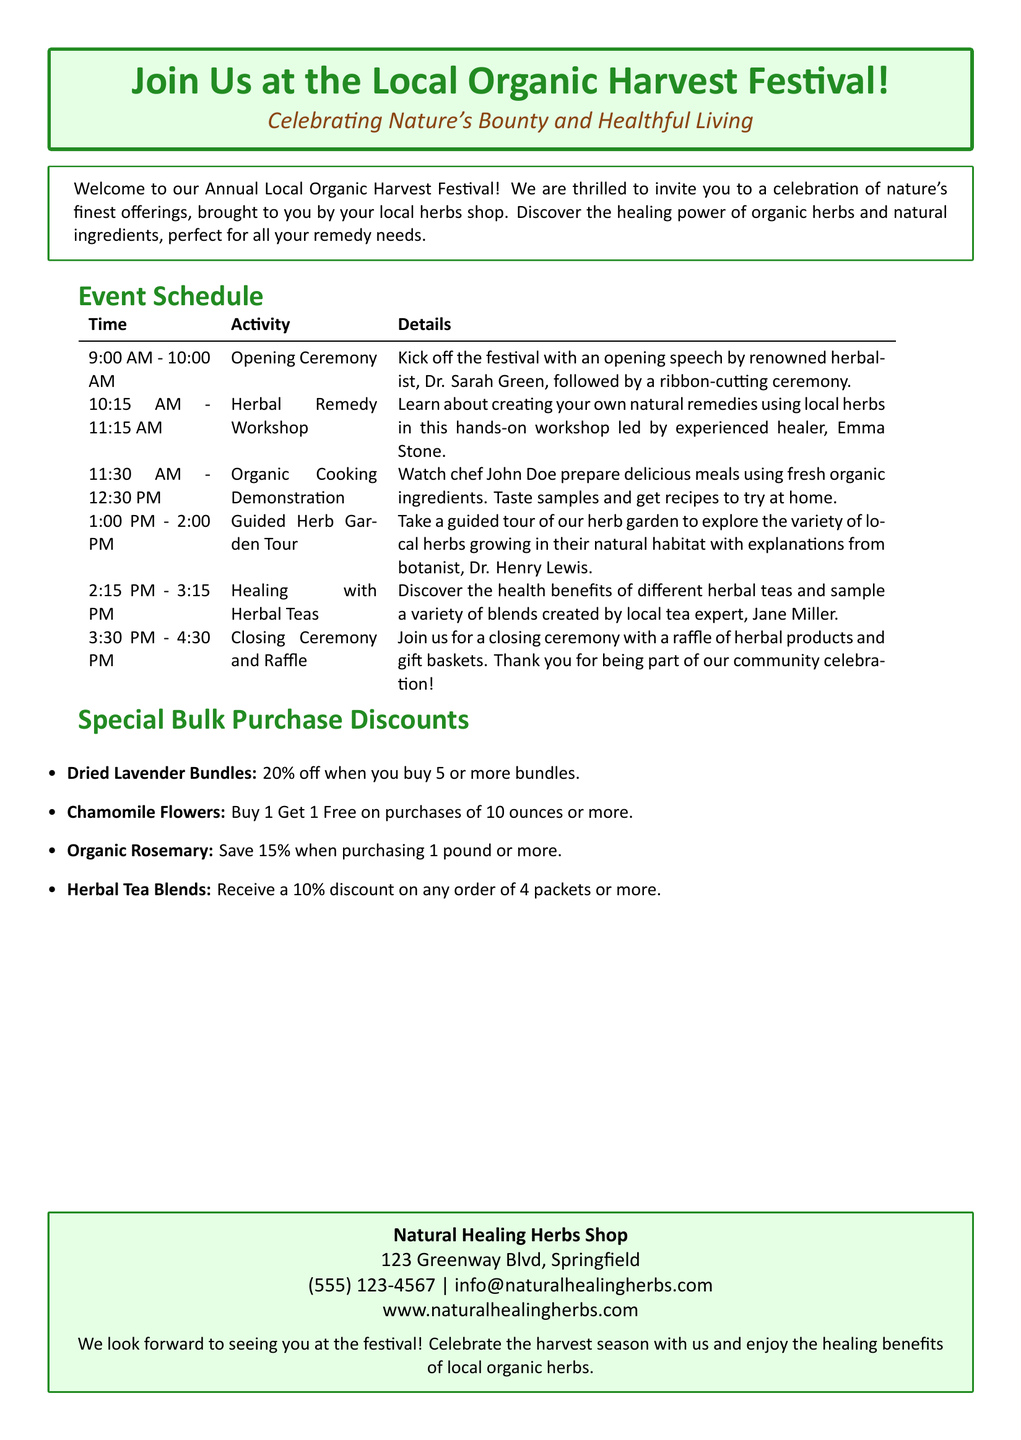What time does the festival begin? The opening ceremony kicks off the festival at 9:00 AM.
Answer: 9:00 AM Who is leading the Herbal Remedy Workshop? The workshop is led by experienced healer, Emma Stone.
Answer: Emma Stone What is the discount for purchasing 1 pound or more of Organic Rosemary? The document states that you save 15% on this purchase.
Answer: 15% How many ounces must be purchased to qualify for the Buy 1 Get 1 Free offer on Chamomile Flowers? The offer is available on purchases of 10 ounces or more.
Answer: 10 ounces What is the last activity scheduled at the festival? The last activity listed in the schedule is the closing ceremony and raffle.
Answer: Closing Ceremony and Raffle What should attendees expect during the Guided Herb Garden Tour? Attendees will explore a variety of local herbs with explanations from Dr. Henry Lewis.
Answer: Explore local herbs Is there a email contact provided in the advertisement? The document includes an email contact for inquiries related to the festival.
Answer: info@naturalhealingherbs.com What percentage discount is offered for Herbal Tea Blends when purchasing 4 packets or more? The advertisement offers a 10% discount for bulk purchases of this product.
Answer: 10% Which chef will conduct the Organic Cooking Demonstration? The cooking demonstration will be led by chef John Doe.
Answer: John Doe 